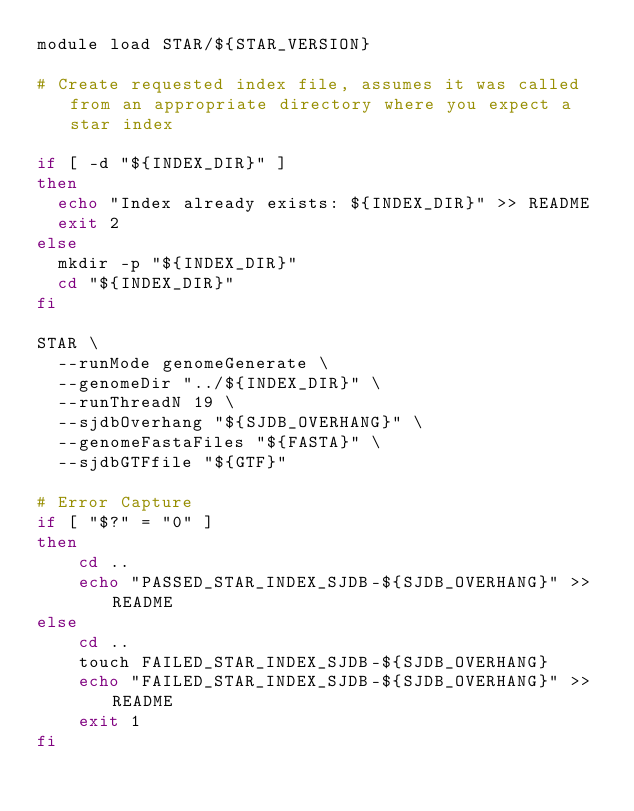Convert code to text. <code><loc_0><loc_0><loc_500><loc_500><_Bash_>module load STAR/${STAR_VERSION}

# Create requested index file, assumes it was called from an appropriate directory where you expect a star index

if [ -d "${INDEX_DIR}" ]
then
  echo "Index already exists: ${INDEX_DIR}" >> README
  exit 2
else
  mkdir -p "${INDEX_DIR}"
  cd "${INDEX_DIR}"
fi

STAR \
  --runMode genomeGenerate \
  --genomeDir "../${INDEX_DIR}" \
  --runThreadN 19 \
  --sjdbOverhang "${SJDB_OVERHANG}" \
  --genomeFastaFiles "${FASTA}" \
  --sjdbGTFfile "${GTF}"

# Error Capture
if [ "$?" = "0" ]
then
    cd ..
    echo "PASSED_STAR_INDEX_SJDB-${SJDB_OVERHANG}" >> README
else
    cd ..
    touch FAILED_STAR_INDEX_SJDB-${SJDB_OVERHANG}
    echo "FAILED_STAR_INDEX_SJDB-${SJDB_OVERHANG}" >> README
    exit 1
fi
</code> 